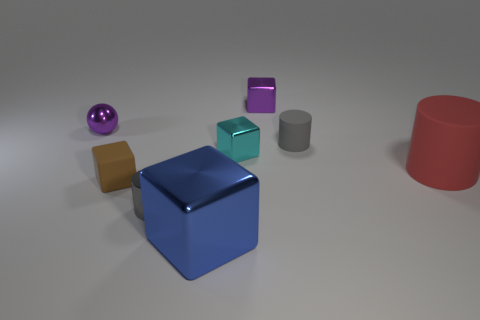How many objects in the picture have circular shapes? There is one object with a circular shape evident in the image, which is the purple sphere. 